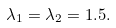Convert formula to latex. <formula><loc_0><loc_0><loc_500><loc_500>\lambda _ { 1 } = \lambda _ { 2 } = 1 . 5 .</formula> 